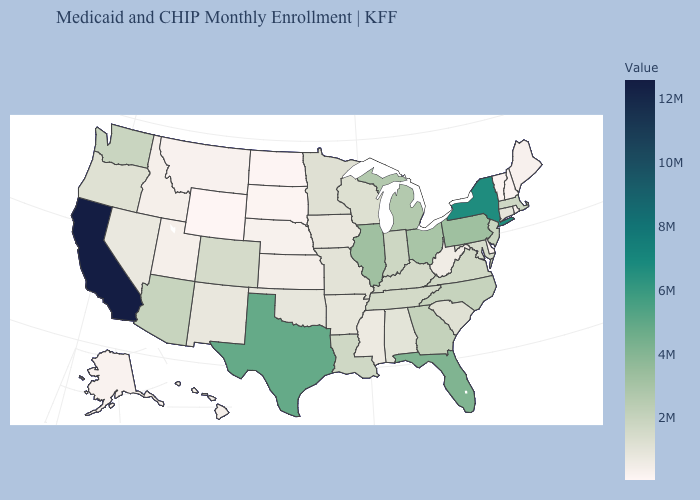Does Wyoming have the lowest value in the USA?
Give a very brief answer. Yes. Does Delaware have the lowest value in the South?
Short answer required. Yes. Does Alabama have a higher value than Michigan?
Quick response, please. No. 